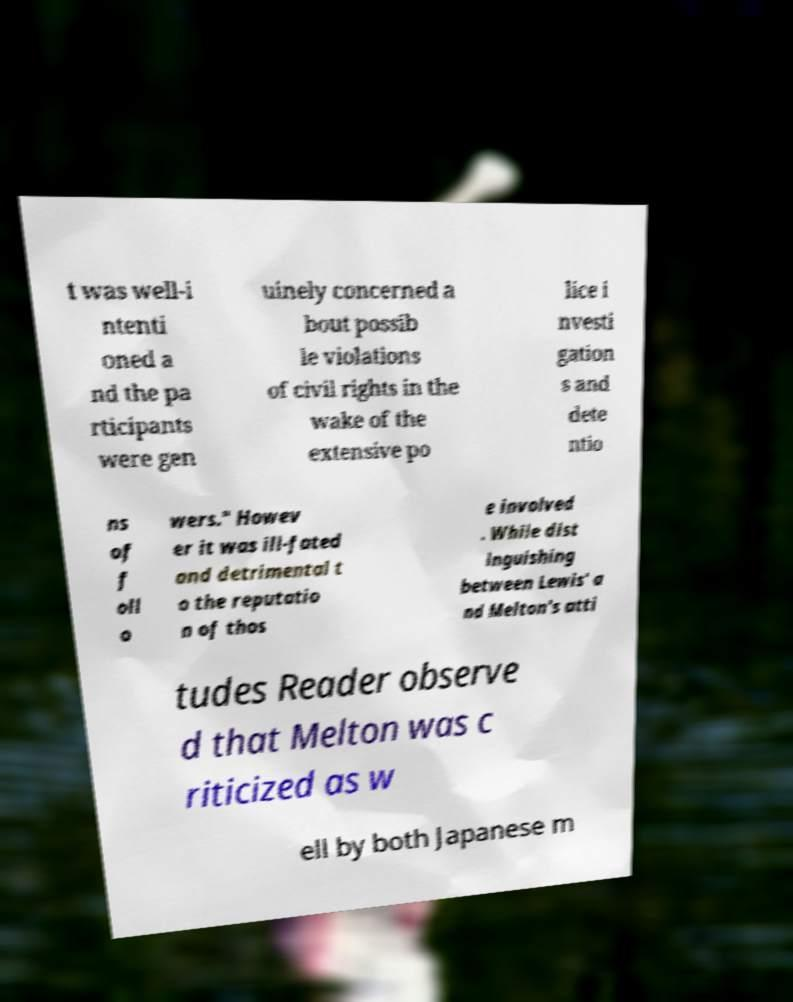For documentation purposes, I need the text within this image transcribed. Could you provide that? t was well-i ntenti oned a nd the pa rticipants were gen uinely concerned a bout possib le violations of civil rights in the wake of the extensive po lice i nvesti gation s and dete ntio ns of f oll o wers." Howev er it was ill-fated and detrimental t o the reputatio n of thos e involved . While dist inguishing between Lewis' a nd Melton's atti tudes Reader observe d that Melton was c riticized as w ell by both Japanese m 